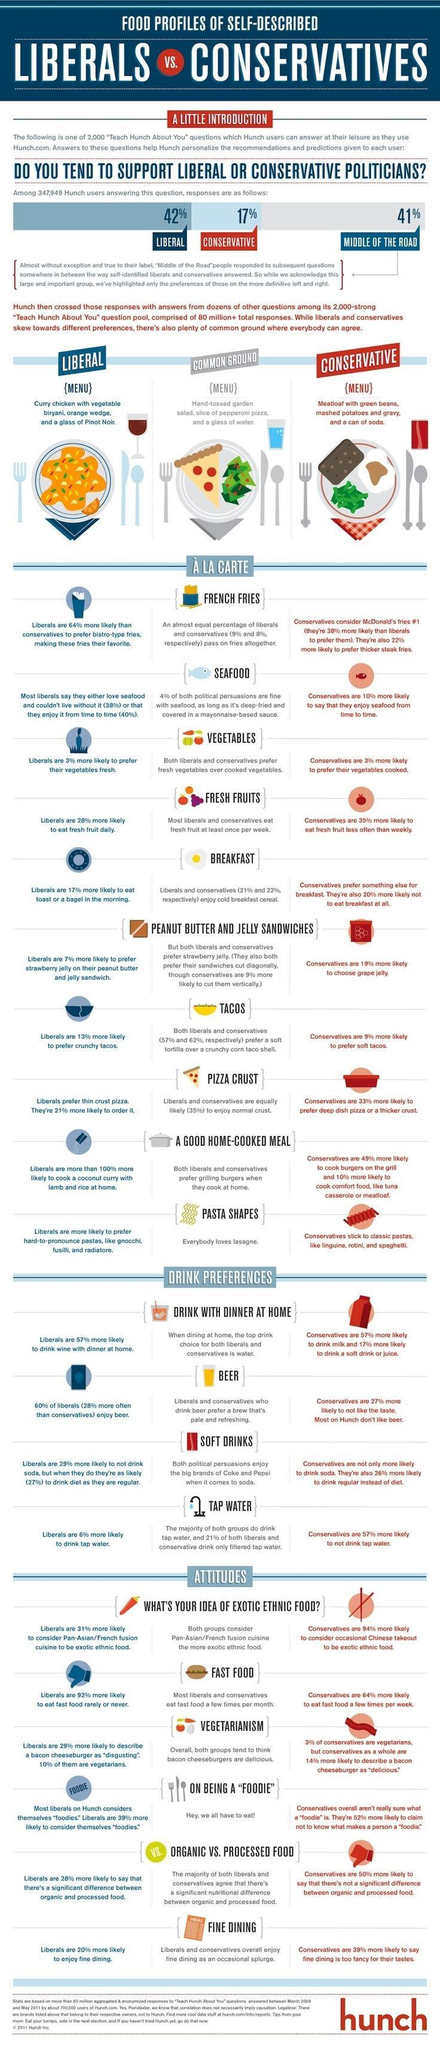Which type of pasta is enjoyed by people of both political preferences?
Answer the question with a short phrase. Lasagne What comfort foods are conservatives likely to prepare at home? tuna casserole or meatloaf Who are more likely to prefer deep dish pizza or thicker crust? Conservatives Which group is more likely to prefer thicker steak fries? Conservatives Which group is more likely to have a bagel or toast in the morning? Liberals Which group preferred curry chicken more than meatloaf? Liberals Who is more likely to choose grape jelly on their peanut butter and jelly sandwich? Conservatives Which type of tacos are 13% of Liberals more likely to prefer? crunchy tacos Who are more likely to prepare coconut curry with lamb and rice at home? Liberals What percent of conservatives enjoy cold breakfast cereal? 22% 